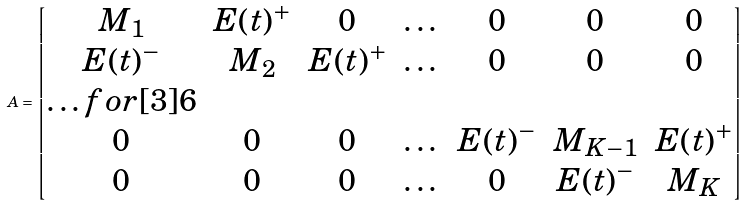Convert formula to latex. <formula><loc_0><loc_0><loc_500><loc_500>A = \begin{bmatrix} M _ { 1 } & E ( t ) ^ { + } & 0 & \dots & 0 & 0 & 0 \\ E ( t ) ^ { - } & M _ { 2 } & E ( t ) ^ { + } & \dots & 0 & 0 & 0 \\ \hdots f o r [ 3 ] { 6 } \\ 0 & 0 & 0 & \dots & E ( t ) ^ { - } & M _ { K - 1 } & E ( t ) ^ { + } \\ 0 & 0 & 0 & \dots & 0 & E ( t ) ^ { - } & M _ { K } \end{bmatrix}</formula> 